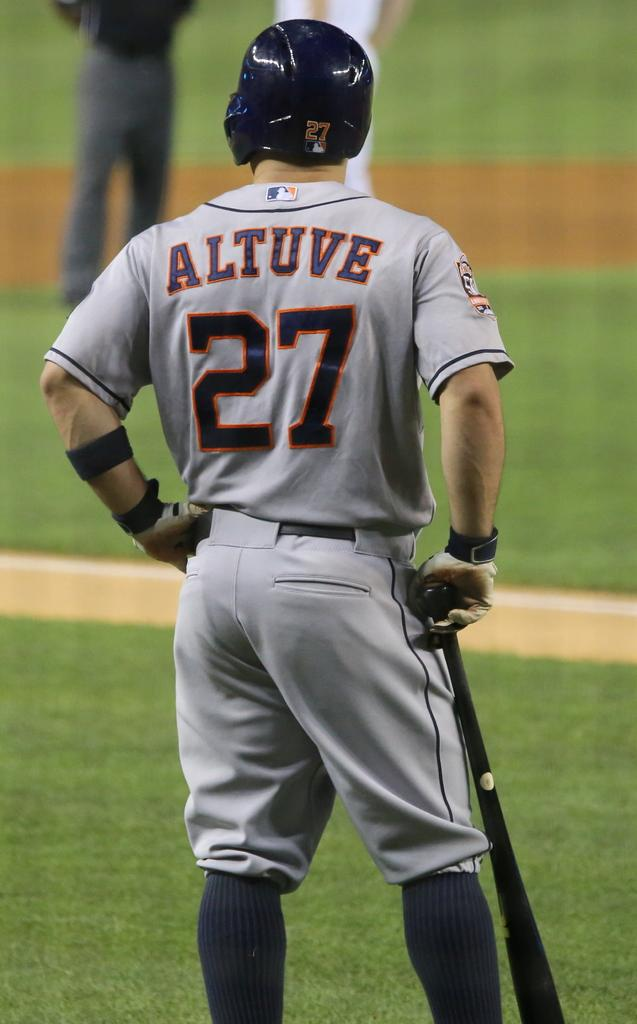How many people are in the image? There are people in the image, but the exact number is not specified. What is the person holding in the image? One person is holding an object in the image, but the specific object is not described. What type of surface is visible under the people's feet? The ground is visible in the image, but its composition is not mentioned. What type of vegetation is present in the image? There is grass in the image, indicating a natural setting. What is the list of items the children are competing for in the image? There is no mention of a list, competition, or children in the image, so this question cannot be answered. 